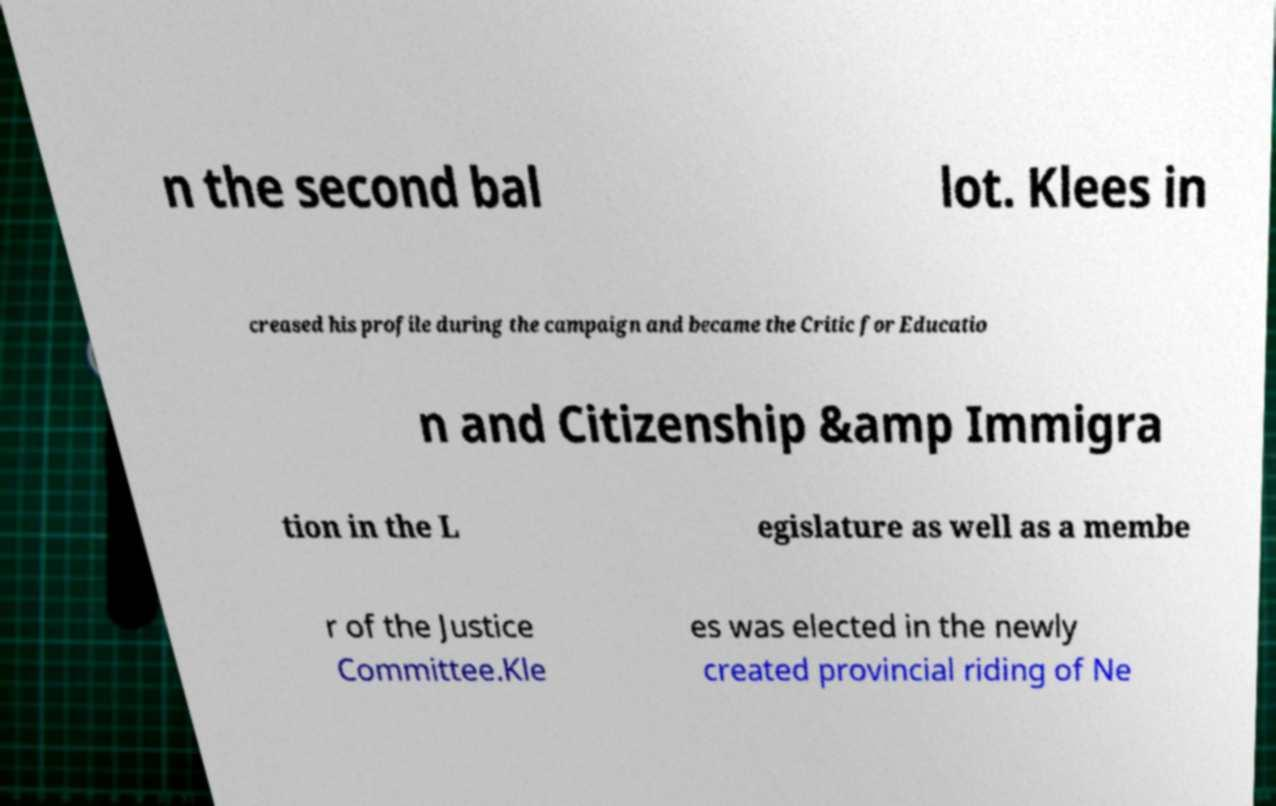Please read and relay the text visible in this image. What does it say? n the second bal lot. Klees in creased his profile during the campaign and became the Critic for Educatio n and Citizenship &amp Immigra tion in the L egislature as well as a membe r of the Justice Committee.Kle es was elected in the newly created provincial riding of Ne 